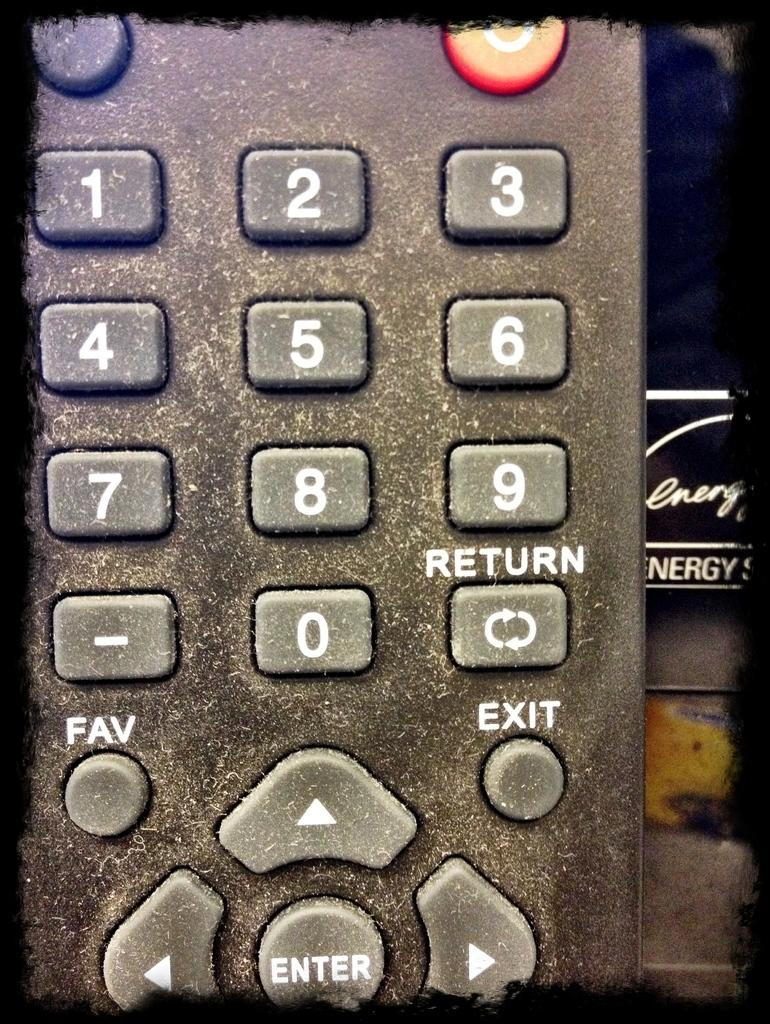<image>
Relay a brief, clear account of the picture shown. A dirty remote shows a return and fav button. 